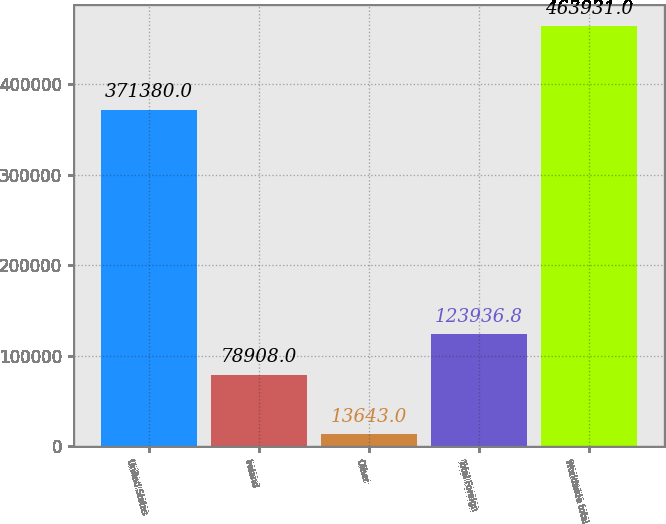<chart> <loc_0><loc_0><loc_500><loc_500><bar_chart><fcel>United States<fcel>Ireland<fcel>Other<fcel>Total Foreign<fcel>Worldwide total<nl><fcel>371380<fcel>78908<fcel>13643<fcel>123937<fcel>463931<nl></chart> 